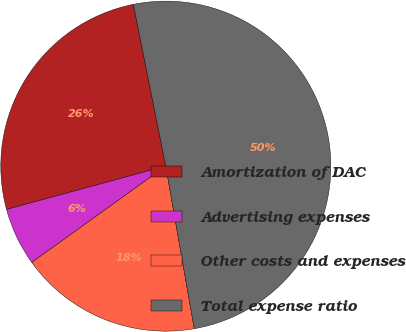Convert chart to OTSL. <chart><loc_0><loc_0><loc_500><loc_500><pie_chart><fcel>Amortization of DAC<fcel>Advertising expenses<fcel>Other costs and expenses<fcel>Total expense ratio<nl><fcel>26.08%<fcel>5.69%<fcel>17.84%<fcel>50.39%<nl></chart> 